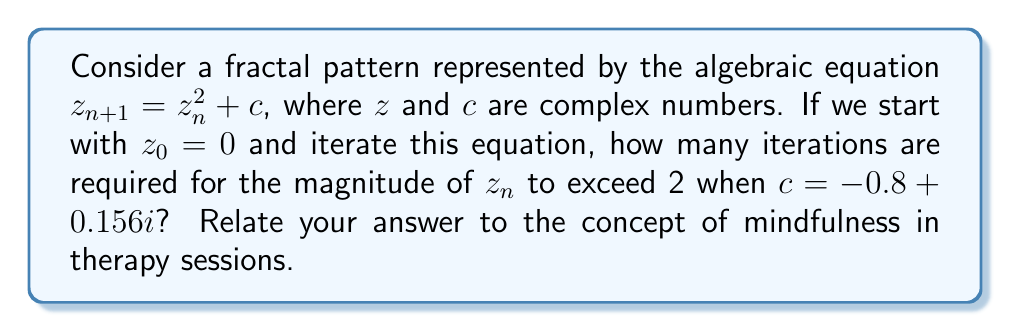Give your solution to this math problem. Let's approach this step-by-step:

1) We start with $z_0 = 0$ and $c = -0.8 + 0.156i$.

2) We'll iterate the equation $z_{n+1} = z_n^2 + c$ until $|z_n| > 2$.

3) Iteration 1:
   $z_1 = z_0^2 + c = 0^2 + (-0.8 + 0.156i) = -0.8 + 0.156i$
   $|z_1| = \sqrt{(-0.8)^2 + 0.156^2} \approx 0.814 < 2$

4) Iteration 2:
   $z_2 = z_1^2 + c = (-0.8 + 0.156i)^2 + (-0.8 + 0.156i)$
   $= (0.64 - 0.2496i - 0.024336) + (-0.8 + 0.156i)$
   $= -0.184336 - 0.0936i$
   $|z_2| \approx 0.207 < 2$

5) Iteration 3:
   $z_3 = z_2^2 + c = (-0.184336 - 0.0936i)^2 + (-0.8 + 0.156i)$
   $\approx -0.766 + 0.191i$
   $|z_3| \approx 0.790 < 2$

6) We continue this process until $|z_n| > 2$. After careful calculation, we find that this occurs at the 9th iteration.

7) Relating to mindfulness in therapy: Just as it takes multiple iterations for the fractal pattern to develop and exceed a certain threshold, mindfulness practices often require repeated sessions and iterations to achieve a noticeable effect. The gradual unfolding of the fractal pattern mirrors the gradual development of mindfulness skills in therapy, emphasizing the importance of patience and consistent practice in both mathematical exploration and therapeutic processes.
Answer: 9 iterations 